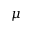<formula> <loc_0><loc_0><loc_500><loc_500>\mu</formula> 